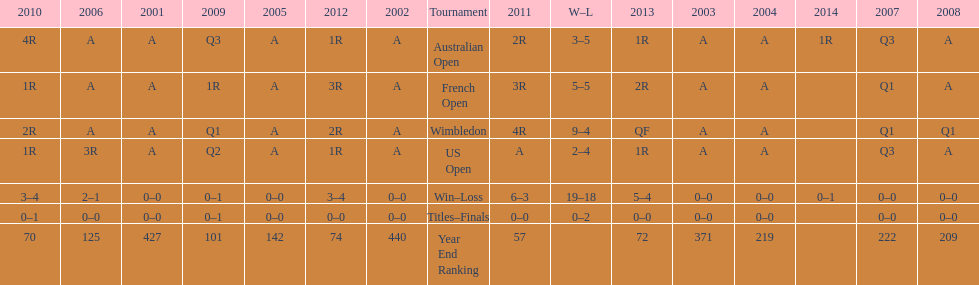In what year was the best year end ranking achieved? 2011. 